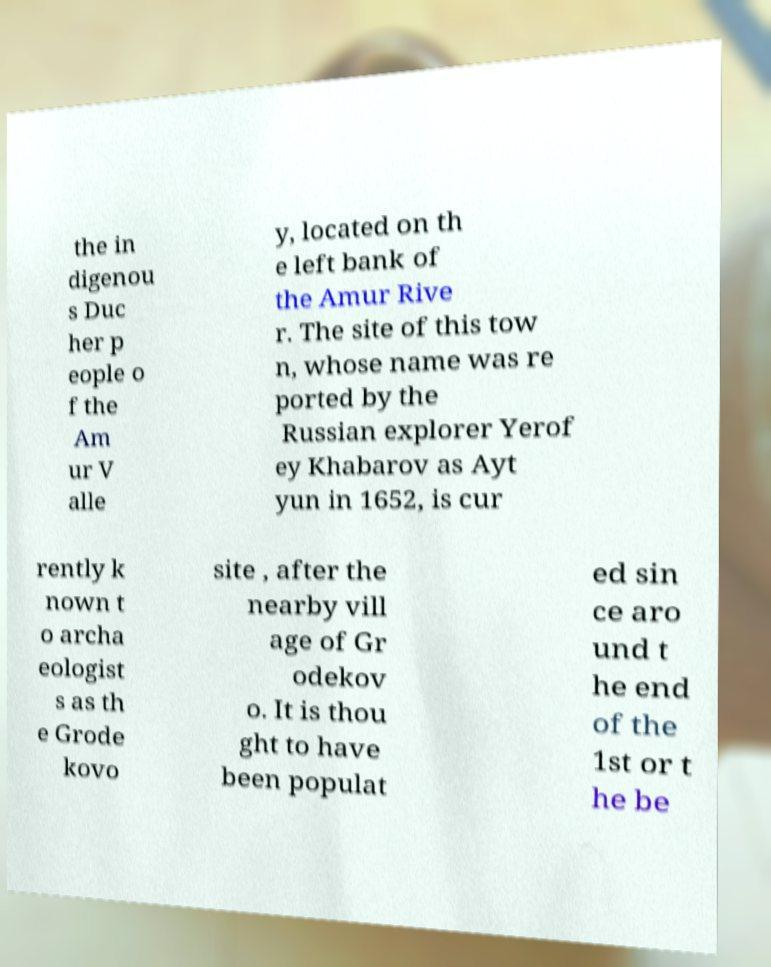Please identify and transcribe the text found in this image. the in digenou s Duc her p eople o f the Am ur V alle y, located on th e left bank of the Amur Rive r. The site of this tow n, whose name was re ported by the Russian explorer Yerof ey Khabarov as Ayt yun in 1652, is cur rently k nown t o archa eologist s as th e Grode kovo site , after the nearby vill age of Gr odekov o. It is thou ght to have been populat ed sin ce aro und t he end of the 1st or t he be 